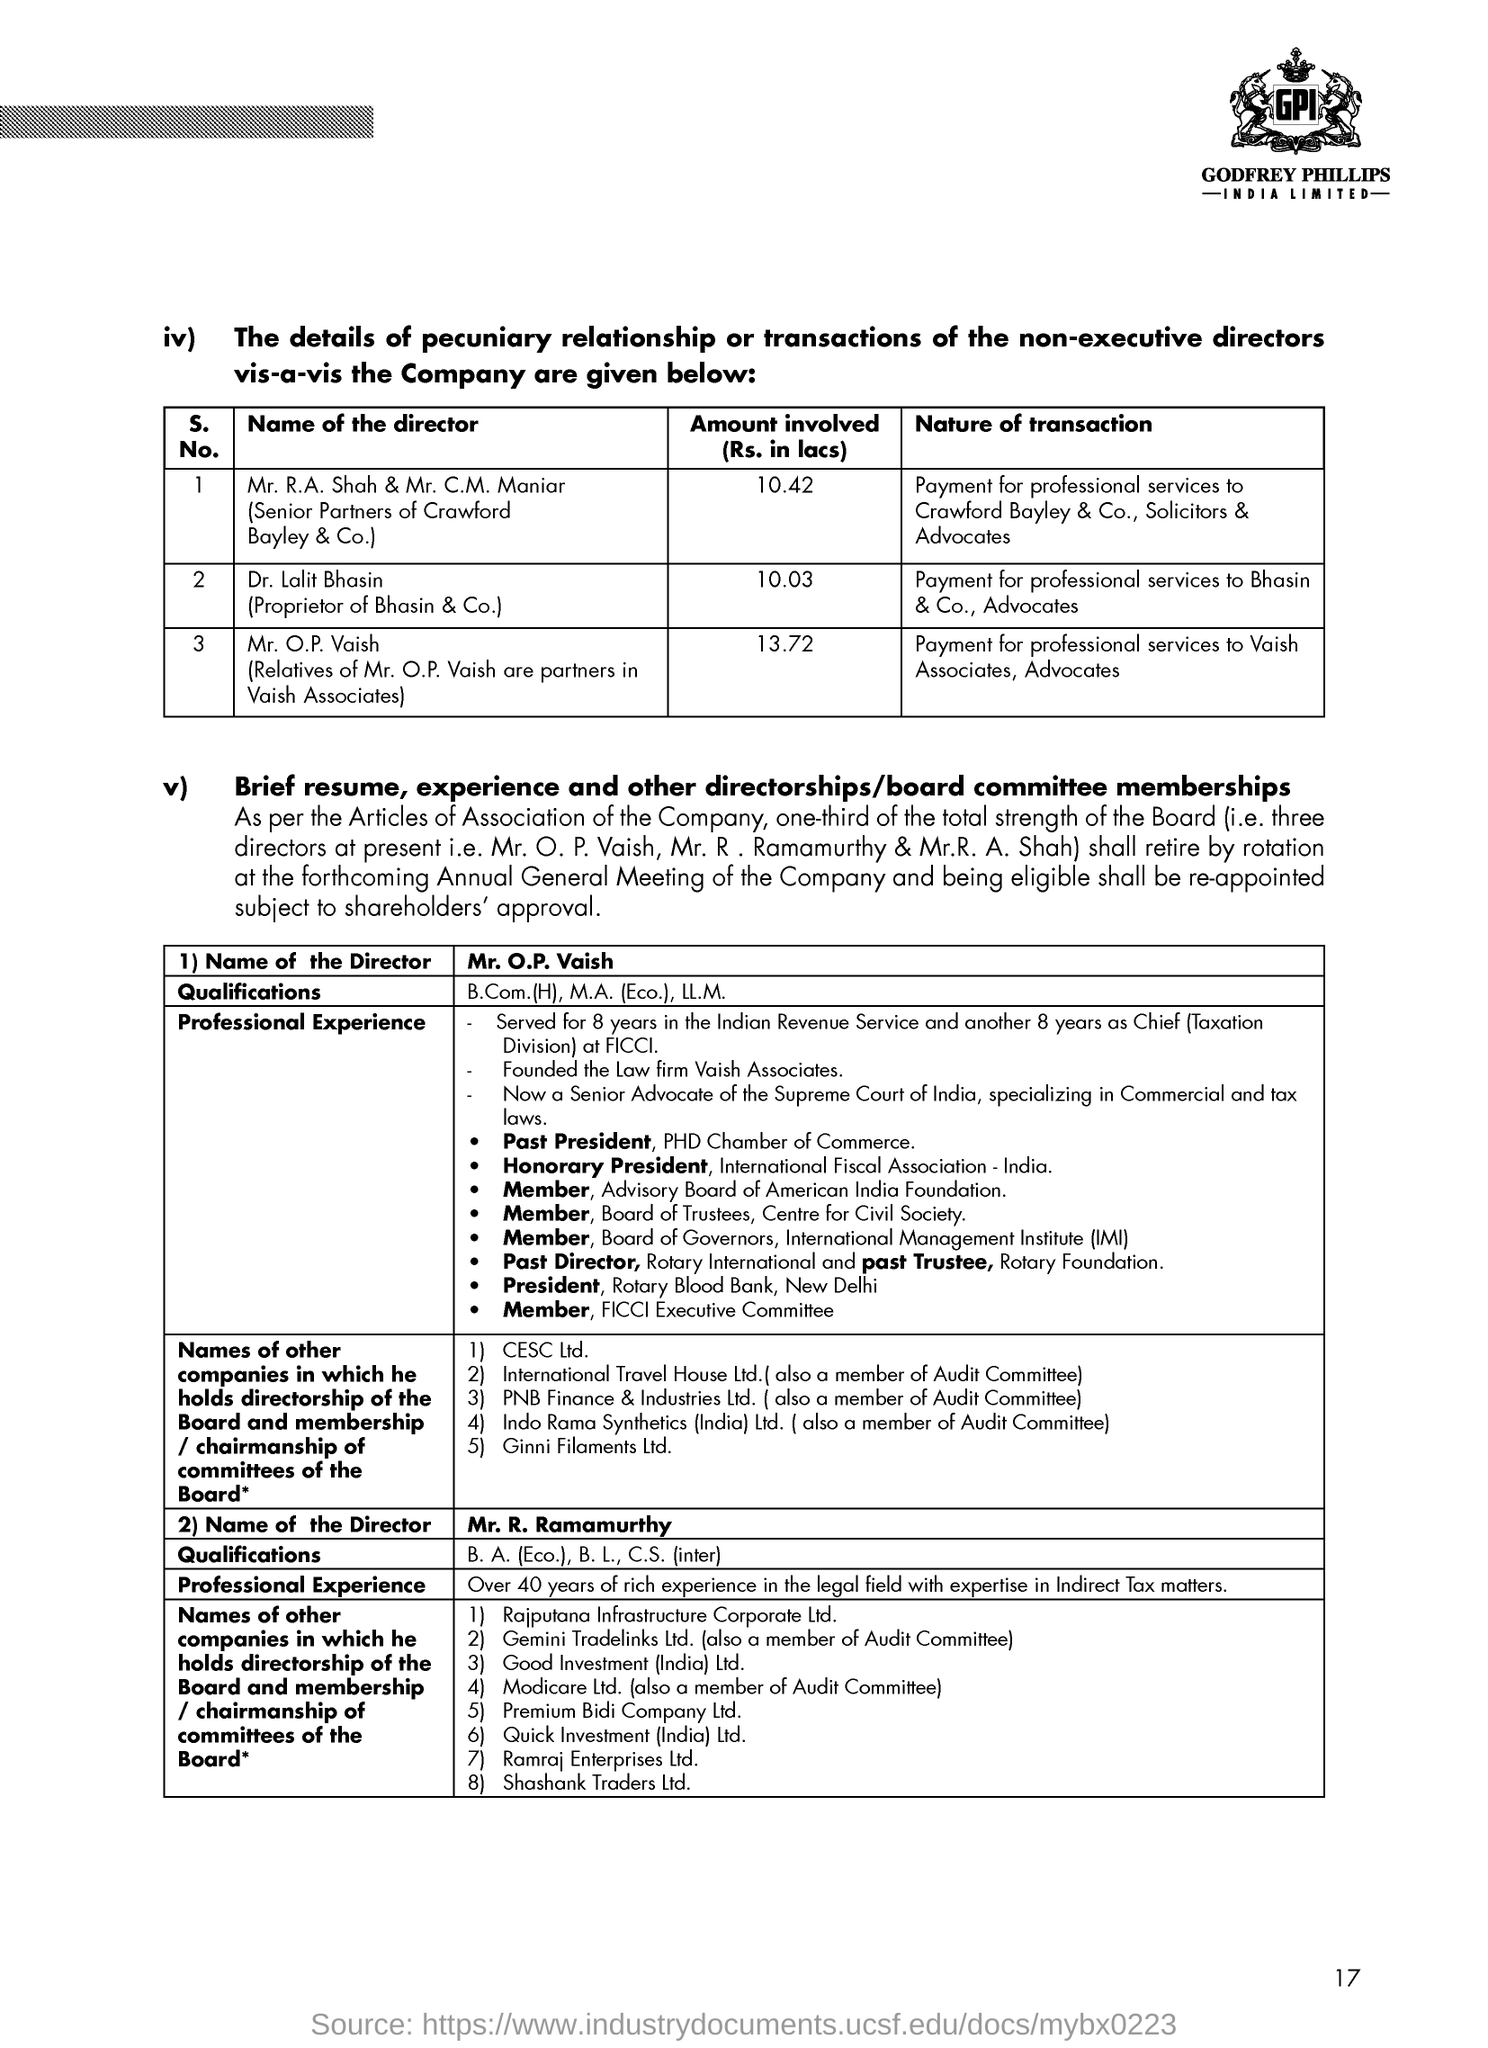List a handful of essential elements in this visual. Dr. Lalit Bhasin made a transaction for the payment of professional services provided by Bhasin & Co., Advocates. 